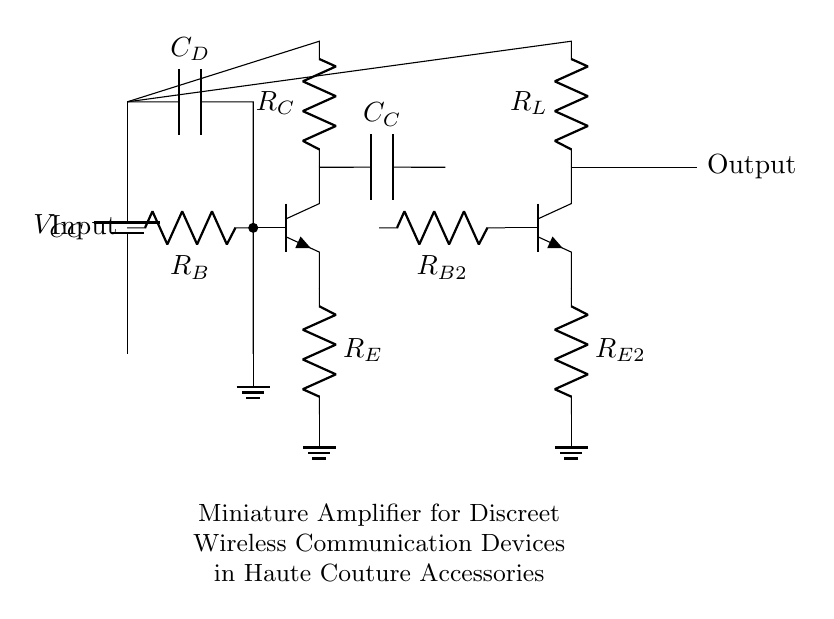What is the power supply voltage in this circuit? The circuit diagram indicates a power supply labeled as V_CC, but does not specify an exact voltage value. It is a crucial component providing power to the entire circuit.
Answer: V_CC What is the purpose of the coupling capacitor, C_C? The coupling capacitor, C_C, allows AC signals to pass while blocking DC voltage. It ensures that the output stage does not have any DC offset affecting its function.
Answer: Allows AC signals What are the two main transistor types used in this amplifier? The circuit includes two npn transistors, which are critical for amplification purposes. Npn transistors amplify current and are commonly used in amplifiers.
Answer: Npn What is the function of resistors R_B and R_{B2}? R_B and R_{B2} serve as biasing resistors for the base terminal of the respective npn transistors. They establish the correct operating point for the transistors to work optimally in the amplifier.
Answer: Biasing How do R_E and R_{E2} contribute to the amplifier's stability? R_E and R_{E2} provide negative feedback in the circuit, improving stability and linearity while preventing thermal runaway by controlling the emitter current of the transistors.
Answer: Negative feedback What component decouples the power supply in this circuit? The decoupling capacitor, C_D, serves the purpose of stabilizing the power supply by filtering out high-frequency noise, ensuring that the circuit operates smoothly and efficiently.
Answer: C_D 